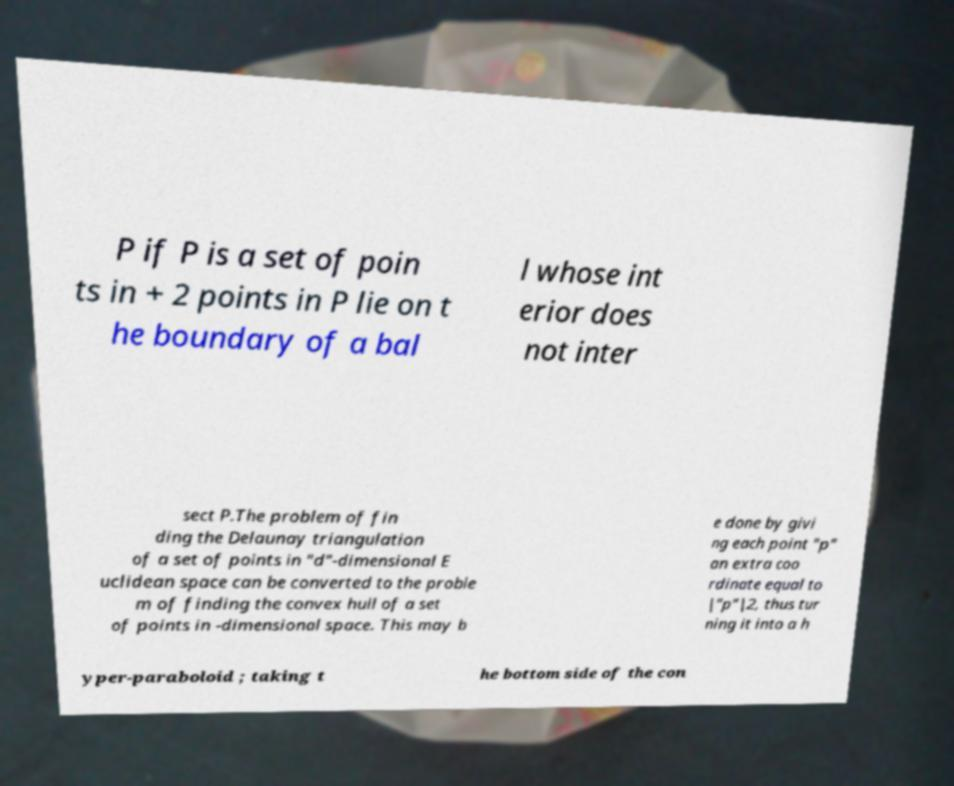Please read and relay the text visible in this image. What does it say? P if P is a set of poin ts in + 2 points in P lie on t he boundary of a bal l whose int erior does not inter sect P.The problem of fin ding the Delaunay triangulation of a set of points in "d"-dimensional E uclidean space can be converted to the proble m of finding the convex hull of a set of points in -dimensional space. This may b e done by givi ng each point "p" an extra coo rdinate equal to |"p"|2, thus tur ning it into a h yper-paraboloid ; taking t he bottom side of the con 